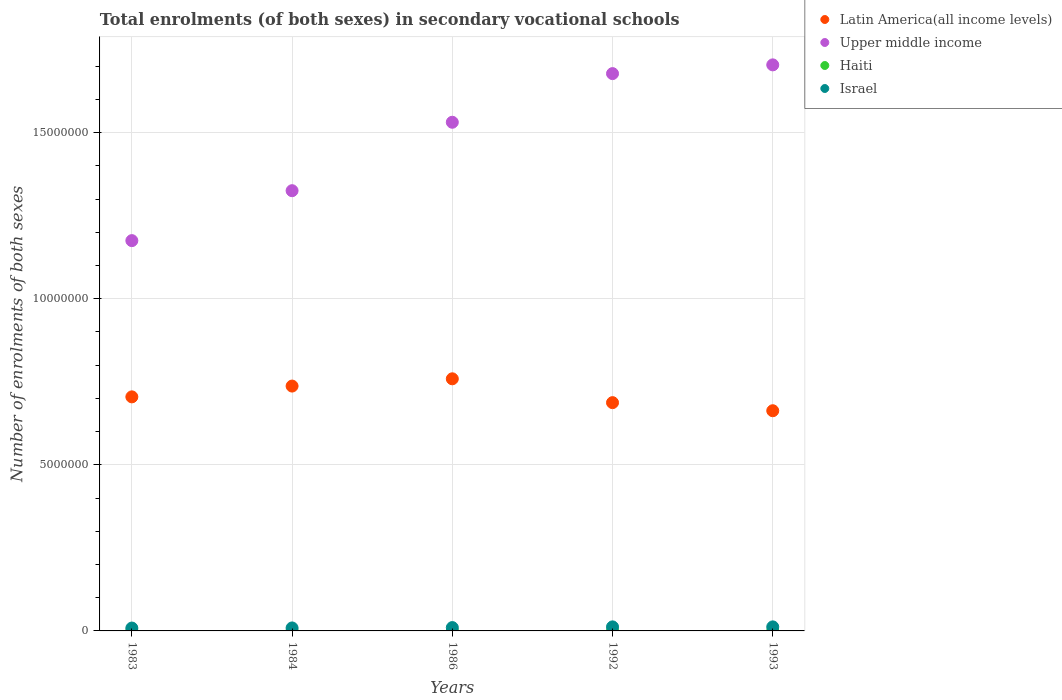Is the number of dotlines equal to the number of legend labels?
Offer a very short reply. Yes. What is the number of enrolments in secondary schools in Upper middle income in 1986?
Keep it short and to the point. 1.53e+07. Across all years, what is the maximum number of enrolments in secondary schools in Upper middle income?
Ensure brevity in your answer.  1.70e+07. Across all years, what is the minimum number of enrolments in secondary schools in Upper middle income?
Offer a terse response. 1.18e+07. In which year was the number of enrolments in secondary schools in Haiti maximum?
Make the answer very short. 1992. In which year was the number of enrolments in secondary schools in Haiti minimum?
Offer a very short reply. 1983. What is the total number of enrolments in secondary schools in Latin America(all income levels) in the graph?
Your answer should be very brief. 3.55e+07. What is the difference between the number of enrolments in secondary schools in Haiti in 1986 and that in 1992?
Make the answer very short. -264. What is the difference between the number of enrolments in secondary schools in Upper middle income in 1983 and the number of enrolments in secondary schools in Latin America(all income levels) in 1986?
Offer a terse response. 4.16e+06. What is the average number of enrolments in secondary schools in Latin America(all income levels) per year?
Ensure brevity in your answer.  7.10e+06. In the year 1986, what is the difference between the number of enrolments in secondary schools in Haiti and number of enrolments in secondary schools in Latin America(all income levels)?
Give a very brief answer. -7.59e+06. In how many years, is the number of enrolments in secondary schools in Haiti greater than 6000000?
Offer a very short reply. 0. What is the ratio of the number of enrolments in secondary schools in Upper middle income in 1984 to that in 1986?
Your answer should be very brief. 0.87. What is the difference between the highest and the lowest number of enrolments in secondary schools in Israel?
Make the answer very short. 3.55e+04. Does the number of enrolments in secondary schools in Israel monotonically increase over the years?
Your answer should be compact. No. Is the number of enrolments in secondary schools in Latin America(all income levels) strictly greater than the number of enrolments in secondary schools in Haiti over the years?
Your answer should be very brief. Yes. Is the number of enrolments in secondary schools in Haiti strictly less than the number of enrolments in secondary schools in Latin America(all income levels) over the years?
Offer a terse response. Yes. Does the graph contain grids?
Provide a succinct answer. Yes. How many legend labels are there?
Keep it short and to the point. 4. What is the title of the graph?
Offer a very short reply. Total enrolments (of both sexes) in secondary vocational schools. What is the label or title of the Y-axis?
Provide a succinct answer. Number of enrolments of both sexes. What is the Number of enrolments of both sexes in Latin America(all income levels) in 1983?
Ensure brevity in your answer.  7.05e+06. What is the Number of enrolments of both sexes in Upper middle income in 1983?
Keep it short and to the point. 1.18e+07. What is the Number of enrolments of both sexes of Haiti in 1983?
Your response must be concise. 3235. What is the Number of enrolments of both sexes in Israel in 1983?
Ensure brevity in your answer.  8.63e+04. What is the Number of enrolments of both sexes of Latin America(all income levels) in 1984?
Offer a very short reply. 7.37e+06. What is the Number of enrolments of both sexes of Upper middle income in 1984?
Provide a succinct answer. 1.33e+07. What is the Number of enrolments of both sexes of Haiti in 1984?
Ensure brevity in your answer.  3235. What is the Number of enrolments of both sexes of Israel in 1984?
Give a very brief answer. 8.96e+04. What is the Number of enrolments of both sexes in Latin America(all income levels) in 1986?
Offer a very short reply. 7.59e+06. What is the Number of enrolments of both sexes of Upper middle income in 1986?
Provide a short and direct response. 1.53e+07. What is the Number of enrolments of both sexes in Haiti in 1986?
Provide a succinct answer. 4336. What is the Number of enrolments of both sexes in Israel in 1986?
Make the answer very short. 1.00e+05. What is the Number of enrolments of both sexes of Latin America(all income levels) in 1992?
Keep it short and to the point. 6.87e+06. What is the Number of enrolments of both sexes in Upper middle income in 1992?
Ensure brevity in your answer.  1.68e+07. What is the Number of enrolments of both sexes of Haiti in 1992?
Your answer should be very brief. 4600. What is the Number of enrolments of both sexes of Israel in 1992?
Provide a short and direct response. 1.22e+05. What is the Number of enrolments of both sexes in Latin America(all income levels) in 1993?
Make the answer very short. 6.63e+06. What is the Number of enrolments of both sexes of Upper middle income in 1993?
Keep it short and to the point. 1.70e+07. What is the Number of enrolments of both sexes of Haiti in 1993?
Offer a terse response. 4600. What is the Number of enrolments of both sexes of Israel in 1993?
Provide a succinct answer. 1.22e+05. Across all years, what is the maximum Number of enrolments of both sexes of Latin America(all income levels)?
Ensure brevity in your answer.  7.59e+06. Across all years, what is the maximum Number of enrolments of both sexes in Upper middle income?
Your answer should be very brief. 1.70e+07. Across all years, what is the maximum Number of enrolments of both sexes of Haiti?
Provide a succinct answer. 4600. Across all years, what is the maximum Number of enrolments of both sexes of Israel?
Offer a very short reply. 1.22e+05. Across all years, what is the minimum Number of enrolments of both sexes of Latin America(all income levels)?
Offer a terse response. 6.63e+06. Across all years, what is the minimum Number of enrolments of both sexes of Upper middle income?
Provide a succinct answer. 1.18e+07. Across all years, what is the minimum Number of enrolments of both sexes of Haiti?
Offer a very short reply. 3235. Across all years, what is the minimum Number of enrolments of both sexes of Israel?
Keep it short and to the point. 8.63e+04. What is the total Number of enrolments of both sexes in Latin America(all income levels) in the graph?
Ensure brevity in your answer.  3.55e+07. What is the total Number of enrolments of both sexes in Upper middle income in the graph?
Offer a very short reply. 7.41e+07. What is the total Number of enrolments of both sexes in Haiti in the graph?
Provide a short and direct response. 2.00e+04. What is the total Number of enrolments of both sexes of Israel in the graph?
Make the answer very short. 5.20e+05. What is the difference between the Number of enrolments of both sexes of Latin America(all income levels) in 1983 and that in 1984?
Your answer should be very brief. -3.25e+05. What is the difference between the Number of enrolments of both sexes in Upper middle income in 1983 and that in 1984?
Your response must be concise. -1.50e+06. What is the difference between the Number of enrolments of both sexes in Haiti in 1983 and that in 1984?
Ensure brevity in your answer.  0. What is the difference between the Number of enrolments of both sexes of Israel in 1983 and that in 1984?
Your response must be concise. -3393. What is the difference between the Number of enrolments of both sexes in Latin America(all income levels) in 1983 and that in 1986?
Your response must be concise. -5.44e+05. What is the difference between the Number of enrolments of both sexes in Upper middle income in 1983 and that in 1986?
Make the answer very short. -3.56e+06. What is the difference between the Number of enrolments of both sexes of Haiti in 1983 and that in 1986?
Provide a succinct answer. -1101. What is the difference between the Number of enrolments of both sexes of Israel in 1983 and that in 1986?
Provide a short and direct response. -1.42e+04. What is the difference between the Number of enrolments of both sexes in Latin America(all income levels) in 1983 and that in 1992?
Your response must be concise. 1.74e+05. What is the difference between the Number of enrolments of both sexes in Upper middle income in 1983 and that in 1992?
Offer a terse response. -5.03e+06. What is the difference between the Number of enrolments of both sexes in Haiti in 1983 and that in 1992?
Your answer should be compact. -1365. What is the difference between the Number of enrolments of both sexes in Israel in 1983 and that in 1992?
Offer a terse response. -3.55e+04. What is the difference between the Number of enrolments of both sexes of Latin America(all income levels) in 1983 and that in 1993?
Make the answer very short. 4.18e+05. What is the difference between the Number of enrolments of both sexes of Upper middle income in 1983 and that in 1993?
Keep it short and to the point. -5.29e+06. What is the difference between the Number of enrolments of both sexes of Haiti in 1983 and that in 1993?
Offer a terse response. -1365. What is the difference between the Number of enrolments of both sexes of Israel in 1983 and that in 1993?
Your response must be concise. -3.54e+04. What is the difference between the Number of enrolments of both sexes of Latin America(all income levels) in 1984 and that in 1986?
Offer a terse response. -2.19e+05. What is the difference between the Number of enrolments of both sexes of Upper middle income in 1984 and that in 1986?
Give a very brief answer. -2.06e+06. What is the difference between the Number of enrolments of both sexes in Haiti in 1984 and that in 1986?
Ensure brevity in your answer.  -1101. What is the difference between the Number of enrolments of both sexes of Israel in 1984 and that in 1986?
Make the answer very short. -1.08e+04. What is the difference between the Number of enrolments of both sexes of Latin America(all income levels) in 1984 and that in 1992?
Give a very brief answer. 4.99e+05. What is the difference between the Number of enrolments of both sexes in Upper middle income in 1984 and that in 1992?
Offer a very short reply. -3.52e+06. What is the difference between the Number of enrolments of both sexes of Haiti in 1984 and that in 1992?
Offer a very short reply. -1365. What is the difference between the Number of enrolments of both sexes of Israel in 1984 and that in 1992?
Give a very brief answer. -3.21e+04. What is the difference between the Number of enrolments of both sexes of Latin America(all income levels) in 1984 and that in 1993?
Your answer should be very brief. 7.42e+05. What is the difference between the Number of enrolments of both sexes in Upper middle income in 1984 and that in 1993?
Offer a very short reply. -3.79e+06. What is the difference between the Number of enrolments of both sexes in Haiti in 1984 and that in 1993?
Ensure brevity in your answer.  -1365. What is the difference between the Number of enrolments of both sexes of Israel in 1984 and that in 1993?
Provide a succinct answer. -3.20e+04. What is the difference between the Number of enrolments of both sexes of Latin America(all income levels) in 1986 and that in 1992?
Keep it short and to the point. 7.18e+05. What is the difference between the Number of enrolments of both sexes of Upper middle income in 1986 and that in 1992?
Keep it short and to the point. -1.46e+06. What is the difference between the Number of enrolments of both sexes in Haiti in 1986 and that in 1992?
Provide a succinct answer. -264. What is the difference between the Number of enrolments of both sexes in Israel in 1986 and that in 1992?
Your response must be concise. -2.13e+04. What is the difference between the Number of enrolments of both sexes of Latin America(all income levels) in 1986 and that in 1993?
Your answer should be compact. 9.61e+05. What is the difference between the Number of enrolments of both sexes in Upper middle income in 1986 and that in 1993?
Give a very brief answer. -1.73e+06. What is the difference between the Number of enrolments of both sexes of Haiti in 1986 and that in 1993?
Your answer should be compact. -264. What is the difference between the Number of enrolments of both sexes of Israel in 1986 and that in 1993?
Offer a terse response. -2.12e+04. What is the difference between the Number of enrolments of both sexes of Latin America(all income levels) in 1992 and that in 1993?
Your answer should be very brief. 2.43e+05. What is the difference between the Number of enrolments of both sexes in Upper middle income in 1992 and that in 1993?
Provide a short and direct response. -2.63e+05. What is the difference between the Number of enrolments of both sexes of Haiti in 1992 and that in 1993?
Your response must be concise. 0. What is the difference between the Number of enrolments of both sexes in Israel in 1992 and that in 1993?
Your response must be concise. 45. What is the difference between the Number of enrolments of both sexes of Latin America(all income levels) in 1983 and the Number of enrolments of both sexes of Upper middle income in 1984?
Provide a succinct answer. -6.21e+06. What is the difference between the Number of enrolments of both sexes of Latin America(all income levels) in 1983 and the Number of enrolments of both sexes of Haiti in 1984?
Make the answer very short. 7.04e+06. What is the difference between the Number of enrolments of both sexes in Latin America(all income levels) in 1983 and the Number of enrolments of both sexes in Israel in 1984?
Offer a terse response. 6.96e+06. What is the difference between the Number of enrolments of both sexes of Upper middle income in 1983 and the Number of enrolments of both sexes of Haiti in 1984?
Offer a terse response. 1.17e+07. What is the difference between the Number of enrolments of both sexes in Upper middle income in 1983 and the Number of enrolments of both sexes in Israel in 1984?
Your answer should be very brief. 1.17e+07. What is the difference between the Number of enrolments of both sexes in Haiti in 1983 and the Number of enrolments of both sexes in Israel in 1984?
Offer a very short reply. -8.64e+04. What is the difference between the Number of enrolments of both sexes in Latin America(all income levels) in 1983 and the Number of enrolments of both sexes in Upper middle income in 1986?
Offer a terse response. -8.27e+06. What is the difference between the Number of enrolments of both sexes in Latin America(all income levels) in 1983 and the Number of enrolments of both sexes in Haiti in 1986?
Your response must be concise. 7.04e+06. What is the difference between the Number of enrolments of both sexes in Latin America(all income levels) in 1983 and the Number of enrolments of both sexes in Israel in 1986?
Provide a succinct answer. 6.95e+06. What is the difference between the Number of enrolments of both sexes in Upper middle income in 1983 and the Number of enrolments of both sexes in Haiti in 1986?
Offer a very short reply. 1.17e+07. What is the difference between the Number of enrolments of both sexes of Upper middle income in 1983 and the Number of enrolments of both sexes of Israel in 1986?
Make the answer very short. 1.17e+07. What is the difference between the Number of enrolments of both sexes in Haiti in 1983 and the Number of enrolments of both sexes in Israel in 1986?
Make the answer very short. -9.72e+04. What is the difference between the Number of enrolments of both sexes in Latin America(all income levels) in 1983 and the Number of enrolments of both sexes in Upper middle income in 1992?
Offer a terse response. -9.73e+06. What is the difference between the Number of enrolments of both sexes in Latin America(all income levels) in 1983 and the Number of enrolments of both sexes in Haiti in 1992?
Offer a very short reply. 7.04e+06. What is the difference between the Number of enrolments of both sexes in Latin America(all income levels) in 1983 and the Number of enrolments of both sexes in Israel in 1992?
Your answer should be compact. 6.93e+06. What is the difference between the Number of enrolments of both sexes of Upper middle income in 1983 and the Number of enrolments of both sexes of Haiti in 1992?
Provide a succinct answer. 1.17e+07. What is the difference between the Number of enrolments of both sexes in Upper middle income in 1983 and the Number of enrolments of both sexes in Israel in 1992?
Give a very brief answer. 1.16e+07. What is the difference between the Number of enrolments of both sexes of Haiti in 1983 and the Number of enrolments of both sexes of Israel in 1992?
Offer a very short reply. -1.19e+05. What is the difference between the Number of enrolments of both sexes in Latin America(all income levels) in 1983 and the Number of enrolments of both sexes in Upper middle income in 1993?
Keep it short and to the point. -1.00e+07. What is the difference between the Number of enrolments of both sexes of Latin America(all income levels) in 1983 and the Number of enrolments of both sexes of Haiti in 1993?
Offer a very short reply. 7.04e+06. What is the difference between the Number of enrolments of both sexes of Latin America(all income levels) in 1983 and the Number of enrolments of both sexes of Israel in 1993?
Ensure brevity in your answer.  6.93e+06. What is the difference between the Number of enrolments of both sexes in Upper middle income in 1983 and the Number of enrolments of both sexes in Haiti in 1993?
Your response must be concise. 1.17e+07. What is the difference between the Number of enrolments of both sexes in Upper middle income in 1983 and the Number of enrolments of both sexes in Israel in 1993?
Give a very brief answer. 1.16e+07. What is the difference between the Number of enrolments of both sexes of Haiti in 1983 and the Number of enrolments of both sexes of Israel in 1993?
Keep it short and to the point. -1.18e+05. What is the difference between the Number of enrolments of both sexes of Latin America(all income levels) in 1984 and the Number of enrolments of both sexes of Upper middle income in 1986?
Make the answer very short. -7.94e+06. What is the difference between the Number of enrolments of both sexes of Latin America(all income levels) in 1984 and the Number of enrolments of both sexes of Haiti in 1986?
Offer a very short reply. 7.37e+06. What is the difference between the Number of enrolments of both sexes of Latin America(all income levels) in 1984 and the Number of enrolments of both sexes of Israel in 1986?
Offer a very short reply. 7.27e+06. What is the difference between the Number of enrolments of both sexes in Upper middle income in 1984 and the Number of enrolments of both sexes in Haiti in 1986?
Your response must be concise. 1.33e+07. What is the difference between the Number of enrolments of both sexes in Upper middle income in 1984 and the Number of enrolments of both sexes in Israel in 1986?
Provide a short and direct response. 1.32e+07. What is the difference between the Number of enrolments of both sexes in Haiti in 1984 and the Number of enrolments of both sexes in Israel in 1986?
Give a very brief answer. -9.72e+04. What is the difference between the Number of enrolments of both sexes of Latin America(all income levels) in 1984 and the Number of enrolments of both sexes of Upper middle income in 1992?
Make the answer very short. -9.41e+06. What is the difference between the Number of enrolments of both sexes in Latin America(all income levels) in 1984 and the Number of enrolments of both sexes in Haiti in 1992?
Your response must be concise. 7.37e+06. What is the difference between the Number of enrolments of both sexes of Latin America(all income levels) in 1984 and the Number of enrolments of both sexes of Israel in 1992?
Keep it short and to the point. 7.25e+06. What is the difference between the Number of enrolments of both sexes in Upper middle income in 1984 and the Number of enrolments of both sexes in Haiti in 1992?
Ensure brevity in your answer.  1.32e+07. What is the difference between the Number of enrolments of both sexes in Upper middle income in 1984 and the Number of enrolments of both sexes in Israel in 1992?
Your answer should be compact. 1.31e+07. What is the difference between the Number of enrolments of both sexes in Haiti in 1984 and the Number of enrolments of both sexes in Israel in 1992?
Provide a succinct answer. -1.19e+05. What is the difference between the Number of enrolments of both sexes in Latin America(all income levels) in 1984 and the Number of enrolments of both sexes in Upper middle income in 1993?
Offer a terse response. -9.67e+06. What is the difference between the Number of enrolments of both sexes in Latin America(all income levels) in 1984 and the Number of enrolments of both sexes in Haiti in 1993?
Your response must be concise. 7.37e+06. What is the difference between the Number of enrolments of both sexes of Latin America(all income levels) in 1984 and the Number of enrolments of both sexes of Israel in 1993?
Keep it short and to the point. 7.25e+06. What is the difference between the Number of enrolments of both sexes of Upper middle income in 1984 and the Number of enrolments of both sexes of Haiti in 1993?
Provide a succinct answer. 1.32e+07. What is the difference between the Number of enrolments of both sexes of Upper middle income in 1984 and the Number of enrolments of both sexes of Israel in 1993?
Give a very brief answer. 1.31e+07. What is the difference between the Number of enrolments of both sexes of Haiti in 1984 and the Number of enrolments of both sexes of Israel in 1993?
Offer a very short reply. -1.18e+05. What is the difference between the Number of enrolments of both sexes of Latin America(all income levels) in 1986 and the Number of enrolments of both sexes of Upper middle income in 1992?
Ensure brevity in your answer.  -9.19e+06. What is the difference between the Number of enrolments of both sexes in Latin America(all income levels) in 1986 and the Number of enrolments of both sexes in Haiti in 1992?
Provide a succinct answer. 7.59e+06. What is the difference between the Number of enrolments of both sexes of Latin America(all income levels) in 1986 and the Number of enrolments of both sexes of Israel in 1992?
Your answer should be very brief. 7.47e+06. What is the difference between the Number of enrolments of both sexes in Upper middle income in 1986 and the Number of enrolments of both sexes in Haiti in 1992?
Provide a short and direct response. 1.53e+07. What is the difference between the Number of enrolments of both sexes in Upper middle income in 1986 and the Number of enrolments of both sexes in Israel in 1992?
Provide a short and direct response. 1.52e+07. What is the difference between the Number of enrolments of both sexes of Haiti in 1986 and the Number of enrolments of both sexes of Israel in 1992?
Your response must be concise. -1.17e+05. What is the difference between the Number of enrolments of both sexes in Latin America(all income levels) in 1986 and the Number of enrolments of both sexes in Upper middle income in 1993?
Offer a very short reply. -9.45e+06. What is the difference between the Number of enrolments of both sexes of Latin America(all income levels) in 1986 and the Number of enrolments of both sexes of Haiti in 1993?
Provide a succinct answer. 7.59e+06. What is the difference between the Number of enrolments of both sexes of Latin America(all income levels) in 1986 and the Number of enrolments of both sexes of Israel in 1993?
Your response must be concise. 7.47e+06. What is the difference between the Number of enrolments of both sexes of Upper middle income in 1986 and the Number of enrolments of both sexes of Haiti in 1993?
Offer a terse response. 1.53e+07. What is the difference between the Number of enrolments of both sexes in Upper middle income in 1986 and the Number of enrolments of both sexes in Israel in 1993?
Ensure brevity in your answer.  1.52e+07. What is the difference between the Number of enrolments of both sexes of Haiti in 1986 and the Number of enrolments of both sexes of Israel in 1993?
Give a very brief answer. -1.17e+05. What is the difference between the Number of enrolments of both sexes of Latin America(all income levels) in 1992 and the Number of enrolments of both sexes of Upper middle income in 1993?
Your answer should be compact. -1.02e+07. What is the difference between the Number of enrolments of both sexes of Latin America(all income levels) in 1992 and the Number of enrolments of both sexes of Haiti in 1993?
Your response must be concise. 6.87e+06. What is the difference between the Number of enrolments of both sexes in Latin America(all income levels) in 1992 and the Number of enrolments of both sexes in Israel in 1993?
Make the answer very short. 6.75e+06. What is the difference between the Number of enrolments of both sexes of Upper middle income in 1992 and the Number of enrolments of both sexes of Haiti in 1993?
Your response must be concise. 1.68e+07. What is the difference between the Number of enrolments of both sexes in Upper middle income in 1992 and the Number of enrolments of both sexes in Israel in 1993?
Ensure brevity in your answer.  1.67e+07. What is the difference between the Number of enrolments of both sexes in Haiti in 1992 and the Number of enrolments of both sexes in Israel in 1993?
Your answer should be compact. -1.17e+05. What is the average Number of enrolments of both sexes of Latin America(all income levels) per year?
Offer a very short reply. 7.10e+06. What is the average Number of enrolments of both sexes of Upper middle income per year?
Keep it short and to the point. 1.48e+07. What is the average Number of enrolments of both sexes of Haiti per year?
Your response must be concise. 4001.2. What is the average Number of enrolments of both sexes in Israel per year?
Your answer should be compact. 1.04e+05. In the year 1983, what is the difference between the Number of enrolments of both sexes of Latin America(all income levels) and Number of enrolments of both sexes of Upper middle income?
Your answer should be compact. -4.70e+06. In the year 1983, what is the difference between the Number of enrolments of both sexes of Latin America(all income levels) and Number of enrolments of both sexes of Haiti?
Your answer should be compact. 7.04e+06. In the year 1983, what is the difference between the Number of enrolments of both sexes in Latin America(all income levels) and Number of enrolments of both sexes in Israel?
Make the answer very short. 6.96e+06. In the year 1983, what is the difference between the Number of enrolments of both sexes of Upper middle income and Number of enrolments of both sexes of Haiti?
Offer a terse response. 1.17e+07. In the year 1983, what is the difference between the Number of enrolments of both sexes of Upper middle income and Number of enrolments of both sexes of Israel?
Make the answer very short. 1.17e+07. In the year 1983, what is the difference between the Number of enrolments of both sexes of Haiti and Number of enrolments of both sexes of Israel?
Provide a short and direct response. -8.30e+04. In the year 1984, what is the difference between the Number of enrolments of both sexes of Latin America(all income levels) and Number of enrolments of both sexes of Upper middle income?
Your response must be concise. -5.88e+06. In the year 1984, what is the difference between the Number of enrolments of both sexes in Latin America(all income levels) and Number of enrolments of both sexes in Haiti?
Your answer should be very brief. 7.37e+06. In the year 1984, what is the difference between the Number of enrolments of both sexes in Latin America(all income levels) and Number of enrolments of both sexes in Israel?
Your answer should be compact. 7.28e+06. In the year 1984, what is the difference between the Number of enrolments of both sexes of Upper middle income and Number of enrolments of both sexes of Haiti?
Keep it short and to the point. 1.33e+07. In the year 1984, what is the difference between the Number of enrolments of both sexes in Upper middle income and Number of enrolments of both sexes in Israel?
Your answer should be very brief. 1.32e+07. In the year 1984, what is the difference between the Number of enrolments of both sexes in Haiti and Number of enrolments of both sexes in Israel?
Your response must be concise. -8.64e+04. In the year 1986, what is the difference between the Number of enrolments of both sexes of Latin America(all income levels) and Number of enrolments of both sexes of Upper middle income?
Your response must be concise. -7.72e+06. In the year 1986, what is the difference between the Number of enrolments of both sexes of Latin America(all income levels) and Number of enrolments of both sexes of Haiti?
Provide a short and direct response. 7.59e+06. In the year 1986, what is the difference between the Number of enrolments of both sexes of Latin America(all income levels) and Number of enrolments of both sexes of Israel?
Keep it short and to the point. 7.49e+06. In the year 1986, what is the difference between the Number of enrolments of both sexes in Upper middle income and Number of enrolments of both sexes in Haiti?
Ensure brevity in your answer.  1.53e+07. In the year 1986, what is the difference between the Number of enrolments of both sexes of Upper middle income and Number of enrolments of both sexes of Israel?
Your answer should be very brief. 1.52e+07. In the year 1986, what is the difference between the Number of enrolments of both sexes in Haiti and Number of enrolments of both sexes in Israel?
Offer a very short reply. -9.61e+04. In the year 1992, what is the difference between the Number of enrolments of both sexes of Latin America(all income levels) and Number of enrolments of both sexes of Upper middle income?
Make the answer very short. -9.91e+06. In the year 1992, what is the difference between the Number of enrolments of both sexes of Latin America(all income levels) and Number of enrolments of both sexes of Haiti?
Your response must be concise. 6.87e+06. In the year 1992, what is the difference between the Number of enrolments of both sexes of Latin America(all income levels) and Number of enrolments of both sexes of Israel?
Ensure brevity in your answer.  6.75e+06. In the year 1992, what is the difference between the Number of enrolments of both sexes in Upper middle income and Number of enrolments of both sexes in Haiti?
Make the answer very short. 1.68e+07. In the year 1992, what is the difference between the Number of enrolments of both sexes of Upper middle income and Number of enrolments of both sexes of Israel?
Provide a succinct answer. 1.67e+07. In the year 1992, what is the difference between the Number of enrolments of both sexes of Haiti and Number of enrolments of both sexes of Israel?
Provide a succinct answer. -1.17e+05. In the year 1993, what is the difference between the Number of enrolments of both sexes in Latin America(all income levels) and Number of enrolments of both sexes in Upper middle income?
Make the answer very short. -1.04e+07. In the year 1993, what is the difference between the Number of enrolments of both sexes in Latin America(all income levels) and Number of enrolments of both sexes in Haiti?
Offer a very short reply. 6.62e+06. In the year 1993, what is the difference between the Number of enrolments of both sexes of Latin America(all income levels) and Number of enrolments of both sexes of Israel?
Offer a very short reply. 6.51e+06. In the year 1993, what is the difference between the Number of enrolments of both sexes of Upper middle income and Number of enrolments of both sexes of Haiti?
Offer a very short reply. 1.70e+07. In the year 1993, what is the difference between the Number of enrolments of both sexes in Upper middle income and Number of enrolments of both sexes in Israel?
Provide a short and direct response. 1.69e+07. In the year 1993, what is the difference between the Number of enrolments of both sexes in Haiti and Number of enrolments of both sexes in Israel?
Offer a terse response. -1.17e+05. What is the ratio of the Number of enrolments of both sexes of Latin America(all income levels) in 1983 to that in 1984?
Ensure brevity in your answer.  0.96. What is the ratio of the Number of enrolments of both sexes in Upper middle income in 1983 to that in 1984?
Your answer should be compact. 0.89. What is the ratio of the Number of enrolments of both sexes of Haiti in 1983 to that in 1984?
Offer a terse response. 1. What is the ratio of the Number of enrolments of both sexes of Israel in 1983 to that in 1984?
Offer a terse response. 0.96. What is the ratio of the Number of enrolments of both sexes in Latin America(all income levels) in 1983 to that in 1986?
Offer a very short reply. 0.93. What is the ratio of the Number of enrolments of both sexes of Upper middle income in 1983 to that in 1986?
Give a very brief answer. 0.77. What is the ratio of the Number of enrolments of both sexes in Haiti in 1983 to that in 1986?
Provide a succinct answer. 0.75. What is the ratio of the Number of enrolments of both sexes of Israel in 1983 to that in 1986?
Your answer should be compact. 0.86. What is the ratio of the Number of enrolments of both sexes in Latin America(all income levels) in 1983 to that in 1992?
Ensure brevity in your answer.  1.03. What is the ratio of the Number of enrolments of both sexes of Upper middle income in 1983 to that in 1992?
Give a very brief answer. 0.7. What is the ratio of the Number of enrolments of both sexes of Haiti in 1983 to that in 1992?
Give a very brief answer. 0.7. What is the ratio of the Number of enrolments of both sexes in Israel in 1983 to that in 1992?
Keep it short and to the point. 0.71. What is the ratio of the Number of enrolments of both sexes of Latin America(all income levels) in 1983 to that in 1993?
Your response must be concise. 1.06. What is the ratio of the Number of enrolments of both sexes of Upper middle income in 1983 to that in 1993?
Keep it short and to the point. 0.69. What is the ratio of the Number of enrolments of both sexes of Haiti in 1983 to that in 1993?
Your answer should be very brief. 0.7. What is the ratio of the Number of enrolments of both sexes of Israel in 1983 to that in 1993?
Ensure brevity in your answer.  0.71. What is the ratio of the Number of enrolments of both sexes of Latin America(all income levels) in 1984 to that in 1986?
Your response must be concise. 0.97. What is the ratio of the Number of enrolments of both sexes in Upper middle income in 1984 to that in 1986?
Provide a short and direct response. 0.87. What is the ratio of the Number of enrolments of both sexes in Haiti in 1984 to that in 1986?
Provide a succinct answer. 0.75. What is the ratio of the Number of enrolments of both sexes in Israel in 1984 to that in 1986?
Offer a terse response. 0.89. What is the ratio of the Number of enrolments of both sexes of Latin America(all income levels) in 1984 to that in 1992?
Your answer should be very brief. 1.07. What is the ratio of the Number of enrolments of both sexes in Upper middle income in 1984 to that in 1992?
Your answer should be very brief. 0.79. What is the ratio of the Number of enrolments of both sexes in Haiti in 1984 to that in 1992?
Make the answer very short. 0.7. What is the ratio of the Number of enrolments of both sexes of Israel in 1984 to that in 1992?
Give a very brief answer. 0.74. What is the ratio of the Number of enrolments of both sexes of Latin America(all income levels) in 1984 to that in 1993?
Your answer should be compact. 1.11. What is the ratio of the Number of enrolments of both sexes in Upper middle income in 1984 to that in 1993?
Your answer should be very brief. 0.78. What is the ratio of the Number of enrolments of both sexes in Haiti in 1984 to that in 1993?
Offer a very short reply. 0.7. What is the ratio of the Number of enrolments of both sexes in Israel in 1984 to that in 1993?
Ensure brevity in your answer.  0.74. What is the ratio of the Number of enrolments of both sexes in Latin America(all income levels) in 1986 to that in 1992?
Give a very brief answer. 1.1. What is the ratio of the Number of enrolments of both sexes of Upper middle income in 1986 to that in 1992?
Ensure brevity in your answer.  0.91. What is the ratio of the Number of enrolments of both sexes in Haiti in 1986 to that in 1992?
Provide a short and direct response. 0.94. What is the ratio of the Number of enrolments of both sexes in Israel in 1986 to that in 1992?
Provide a succinct answer. 0.83. What is the ratio of the Number of enrolments of both sexes of Latin America(all income levels) in 1986 to that in 1993?
Make the answer very short. 1.15. What is the ratio of the Number of enrolments of both sexes of Upper middle income in 1986 to that in 1993?
Make the answer very short. 0.9. What is the ratio of the Number of enrolments of both sexes of Haiti in 1986 to that in 1993?
Your answer should be very brief. 0.94. What is the ratio of the Number of enrolments of both sexes of Israel in 1986 to that in 1993?
Make the answer very short. 0.83. What is the ratio of the Number of enrolments of both sexes of Latin America(all income levels) in 1992 to that in 1993?
Offer a very short reply. 1.04. What is the ratio of the Number of enrolments of both sexes in Upper middle income in 1992 to that in 1993?
Your answer should be very brief. 0.98. What is the ratio of the Number of enrolments of both sexes in Haiti in 1992 to that in 1993?
Provide a succinct answer. 1. What is the difference between the highest and the second highest Number of enrolments of both sexes of Latin America(all income levels)?
Offer a very short reply. 2.19e+05. What is the difference between the highest and the second highest Number of enrolments of both sexes in Upper middle income?
Your response must be concise. 2.63e+05. What is the difference between the highest and the second highest Number of enrolments of both sexes of Haiti?
Give a very brief answer. 0. What is the difference between the highest and the lowest Number of enrolments of both sexes of Latin America(all income levels)?
Give a very brief answer. 9.61e+05. What is the difference between the highest and the lowest Number of enrolments of both sexes in Upper middle income?
Offer a terse response. 5.29e+06. What is the difference between the highest and the lowest Number of enrolments of both sexes of Haiti?
Offer a terse response. 1365. What is the difference between the highest and the lowest Number of enrolments of both sexes of Israel?
Offer a very short reply. 3.55e+04. 